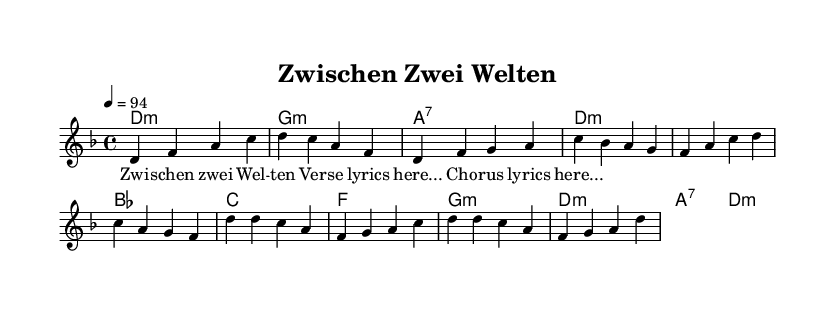What is the key signature of this music? The key signature is D minor, indicated by the two flats in the key signature.
Answer: D minor What is the time signature of this piece? The time signature is 4/4, which means there are four beats in each measure.
Answer: 4/4 What is the tempo marking for the song? The tempo marking is 94 beats per minute, as shown in the tempo notation.
Answer: 94 How many measures are there in the verse section? The verse section consists of four measures, based on the total counts provided for that section in the melody line.
Answer: 4 What is the first note of the chorus? The first note of the chorus is D, as the melody starts with a D note in the measure.
Answer: D How many chords are used in the chorus? The chorus uses four distinct chords: D, F, G, and A, making a total of four chords for the section.
Answer: 4 Which two musical elements mainly express cultural identity in the song? The elements that express cultural identity are the fusion of hip-hop rhythm and Turkish melodic influences, reflecting the artist's heritage.
Answer: Hip-hop and Turkish melody 